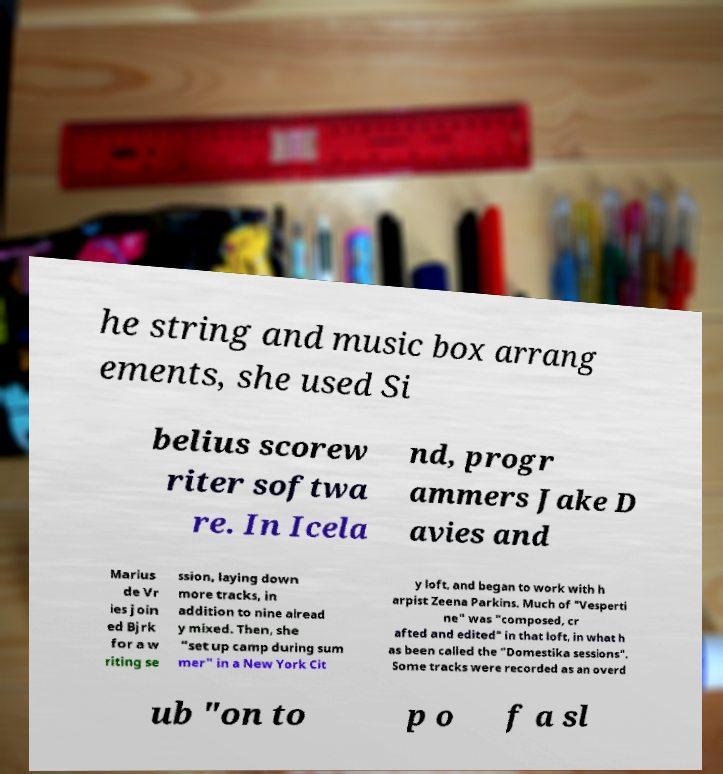Could you extract and type out the text from this image? he string and music box arrang ements, she used Si belius scorew riter softwa re. In Icela nd, progr ammers Jake D avies and Marius de Vr ies join ed Bjrk for a w riting se ssion, laying down more tracks, in addition to nine alread y mixed. Then, she "set up camp during sum mer" in a New York Cit y loft, and began to work with h arpist Zeena Parkins. Much of "Vesperti ne" was "composed, cr afted and edited" in that loft, in what h as been called the "Domestika sessions". Some tracks were recorded as an overd ub "on to p o f a sl 